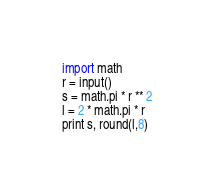Convert code to text. <code><loc_0><loc_0><loc_500><loc_500><_Python_>import math
r = input()
s = math.pi * r ** 2
l = 2 * math.pi * r
print s, round(l,8)</code> 